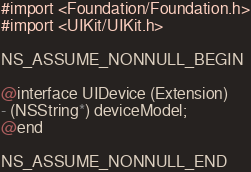Convert code to text. <code><loc_0><loc_0><loc_500><loc_500><_C_>#import <Foundation/Foundation.h>
#import <UIKit/UIKit.h>

NS_ASSUME_NONNULL_BEGIN

@interface UIDevice (Extension)
- (NSString*) deviceModel;
@end

NS_ASSUME_NONNULL_END
</code> 